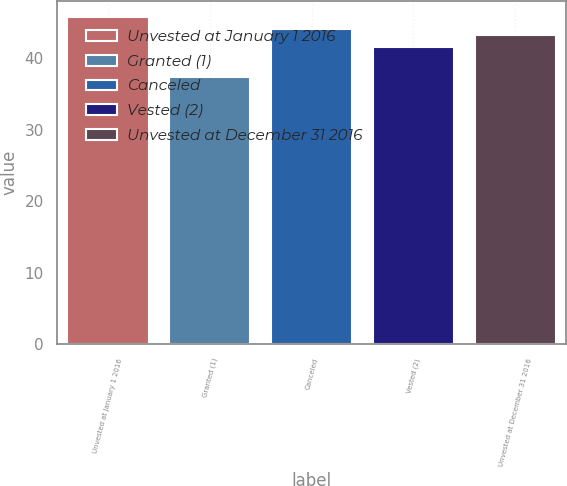Convert chart to OTSL. <chart><loc_0><loc_0><loc_500><loc_500><bar_chart><fcel>Unvested at January 1 2016<fcel>Granted (1)<fcel>Canceled<fcel>Vested (2)<fcel>Unvested at December 31 2016<nl><fcel>45.73<fcel>37.35<fcel>44.08<fcel>41.63<fcel>43.24<nl></chart> 